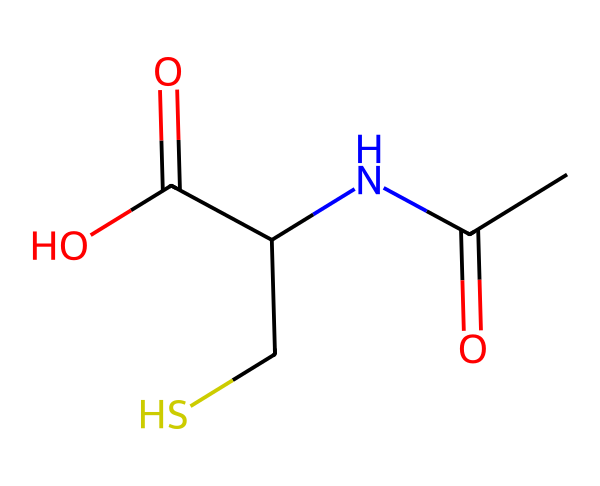What is the molecular formula of N-acetylcysteine? To find the molecular formula, count the number of each type of atom represented in the SMILES. The structure indicates 5 carbon (C), 9 hydrogen (H), 1 nitrogen (N), 3 oxygen (O), and 1 sulfur (S). Therefore, the molecular formula is C5H9NO3S.
Answer: C5H9NO3S How many carbon atoms are present in N-acetylcysteine? By analyzing the SMILES representation, I can identify the number of 'C' symbols, which represent carbon atoms. In this case, there are 5 carbon atoms.
Answer: 5 What functional groups are present in N-acetylcysteine? Looking at the structure, I can identify several functional groups: an amine (–NH), a carboxylic acid (–COOH), and a thiol (–SH). These are critical for its biochemical activity.
Answer: amine, carboxylic acid, thiol What type of compound is N-acetylcysteine? N-acetylcysteine contains a sulfur atom and a thiol group (-SH) indicating that it is a thiol or a sulfur-containing compound. This classification helps in understanding its role as an antioxidant.
Answer: thiol What is the significance of the sulfur atom in N-acetylcysteine? The sulfur atom in N-acetylcysteine is a key part of its antioxidant properties. It allows the molecule to donate electrons, helping toNeutralize free radicals, which can cause oxidative stress and damage to cells.
Answer: antioxidant 